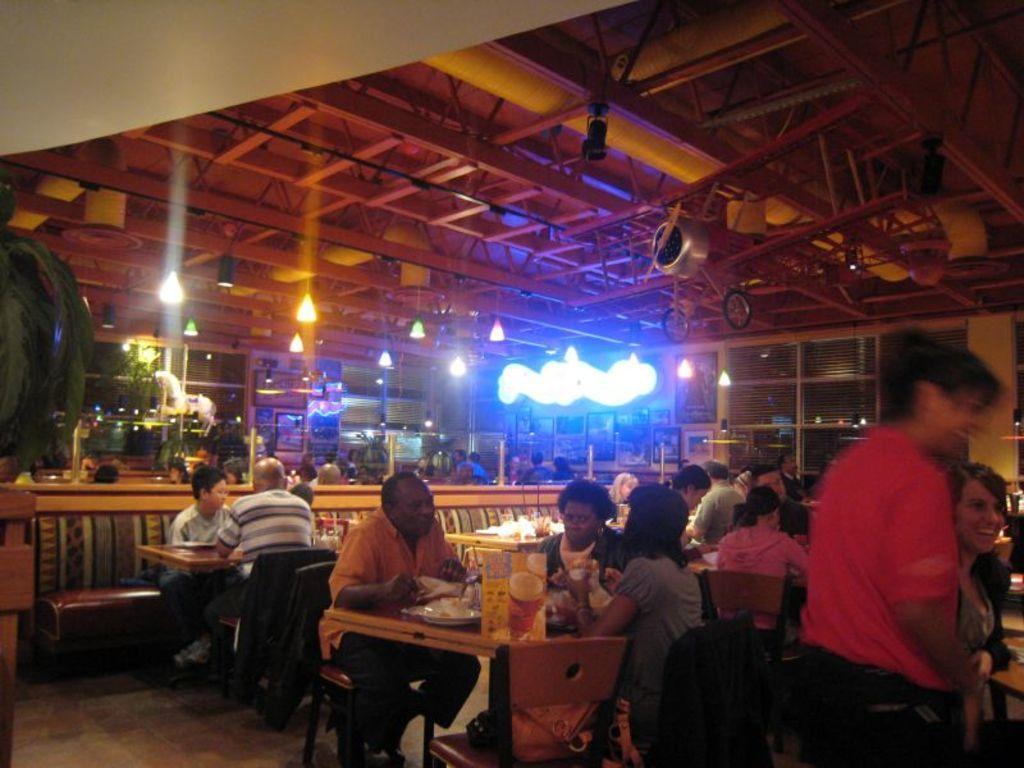Can you describe this image briefly? Lights are attached to the rooftop. Most of the persons are sitting on a chair. On a table there are things. This person is standing. 